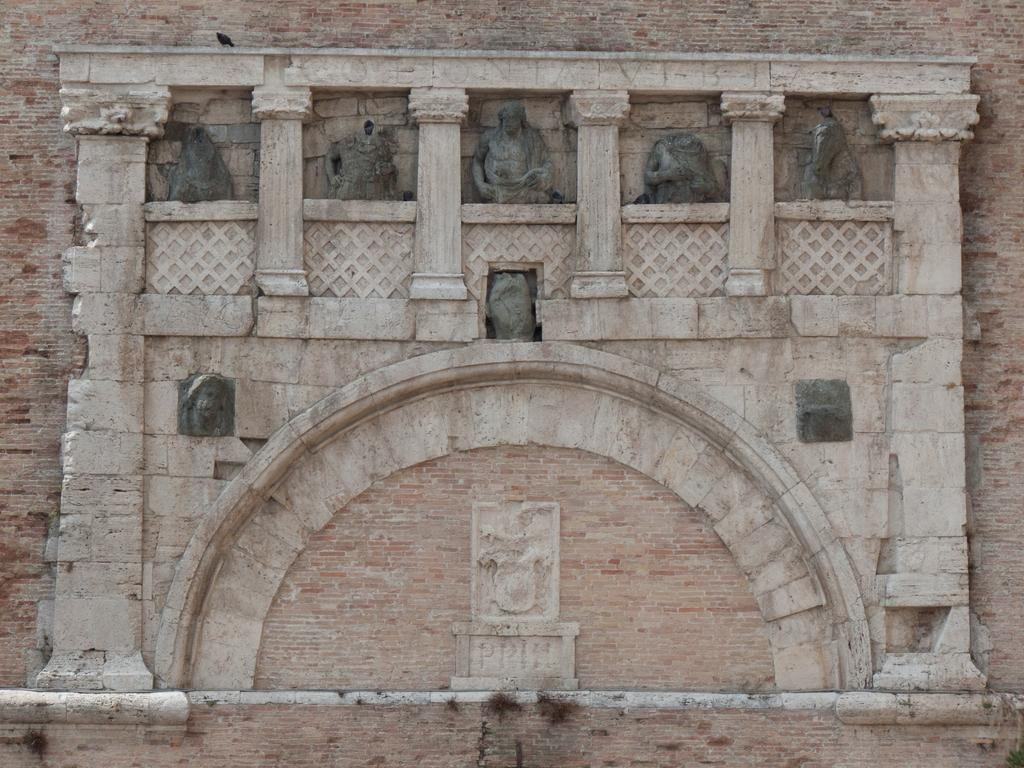What is present on the wall in the image? There are carvings and sculptures on the wall in the image. Can you describe the carvings on the wall? Unfortunately, the details of the carvings cannot be discerned from the image. What type of art can be seen on the wall? The wall features both carvings and sculptures, which are forms of visual art. What type of ring can be seen on the beast's finger in the image? There is no beast or ring present in the image; it only features a wall with carvings and sculptures. 